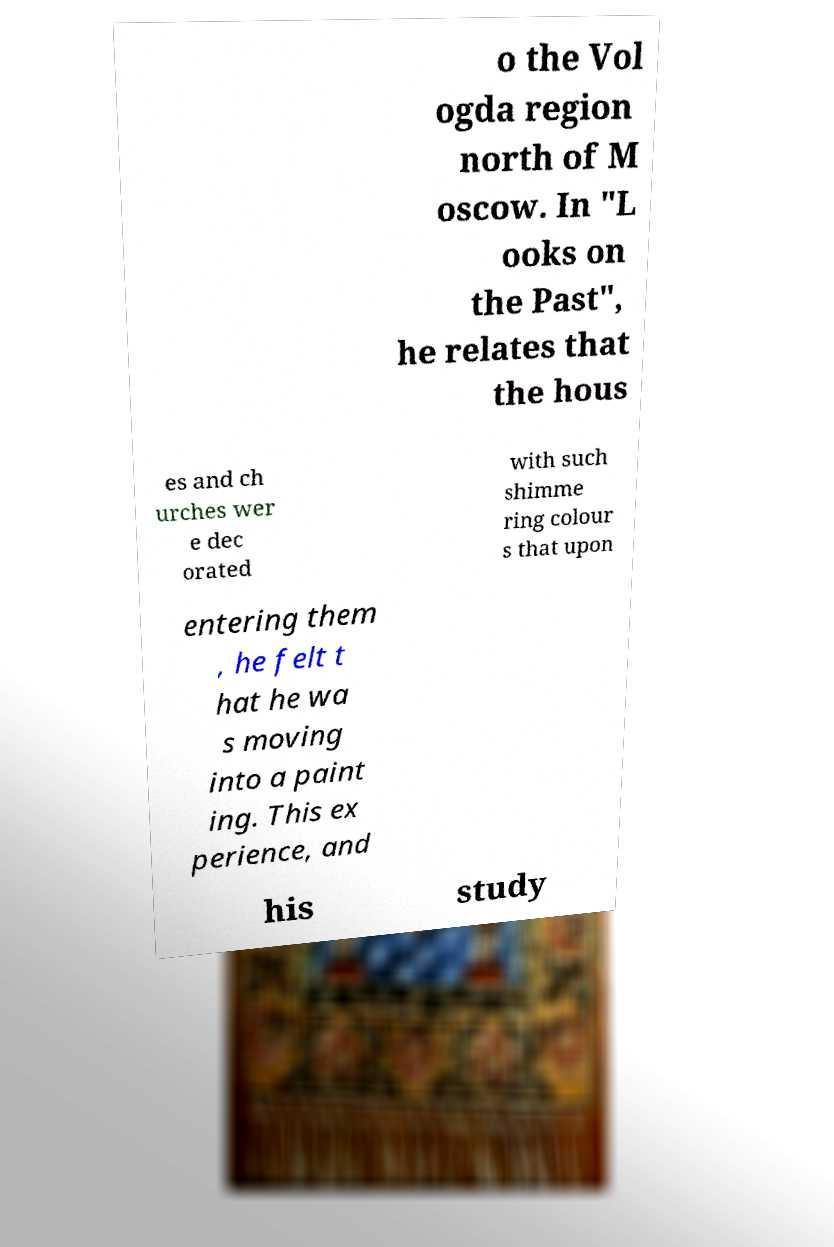Please identify and transcribe the text found in this image. o the Vol ogda region north of M oscow. In "L ooks on the Past", he relates that the hous es and ch urches wer e dec orated with such shimme ring colour s that upon entering them , he felt t hat he wa s moving into a paint ing. This ex perience, and his study 